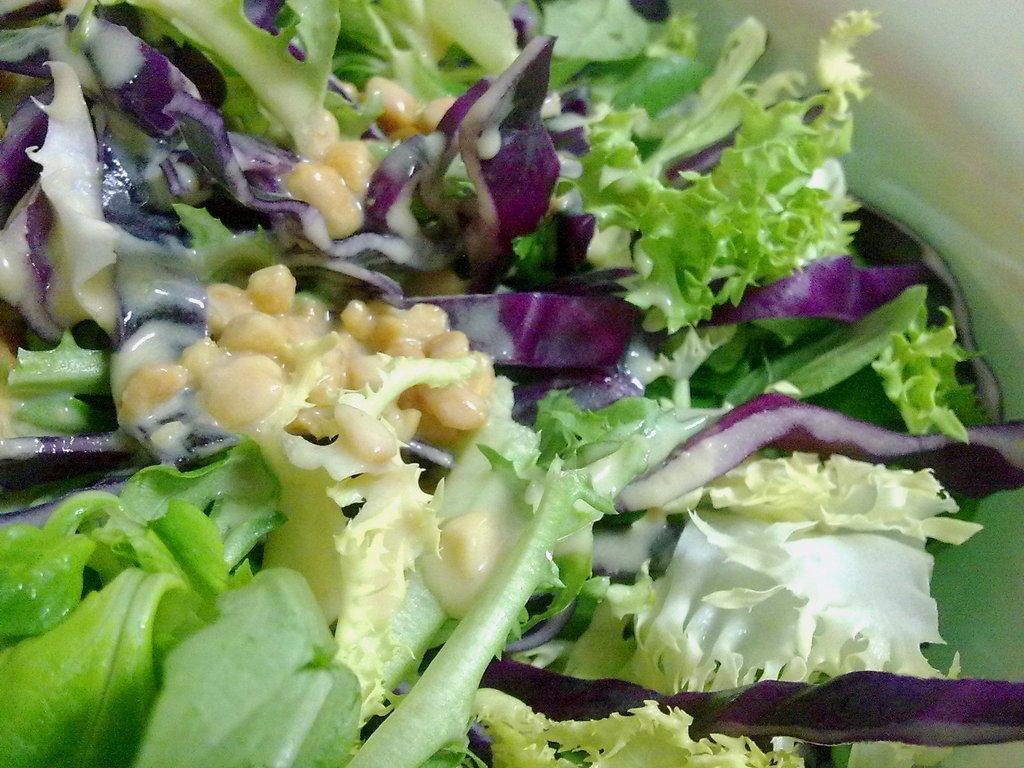In one or two sentences, can you explain what this image depicts? This image consists of salad in which we can see the leaves and seeds. 